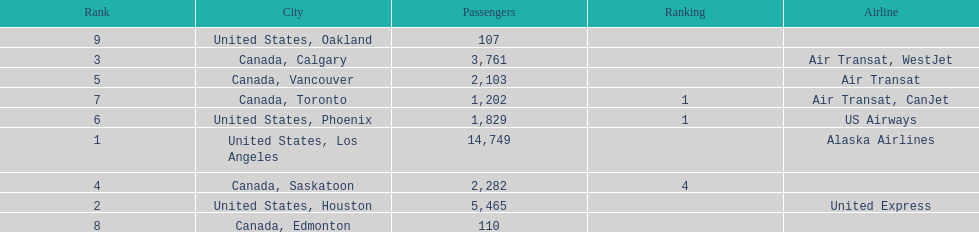Which airline carries the most passengers? Alaska Airlines. 